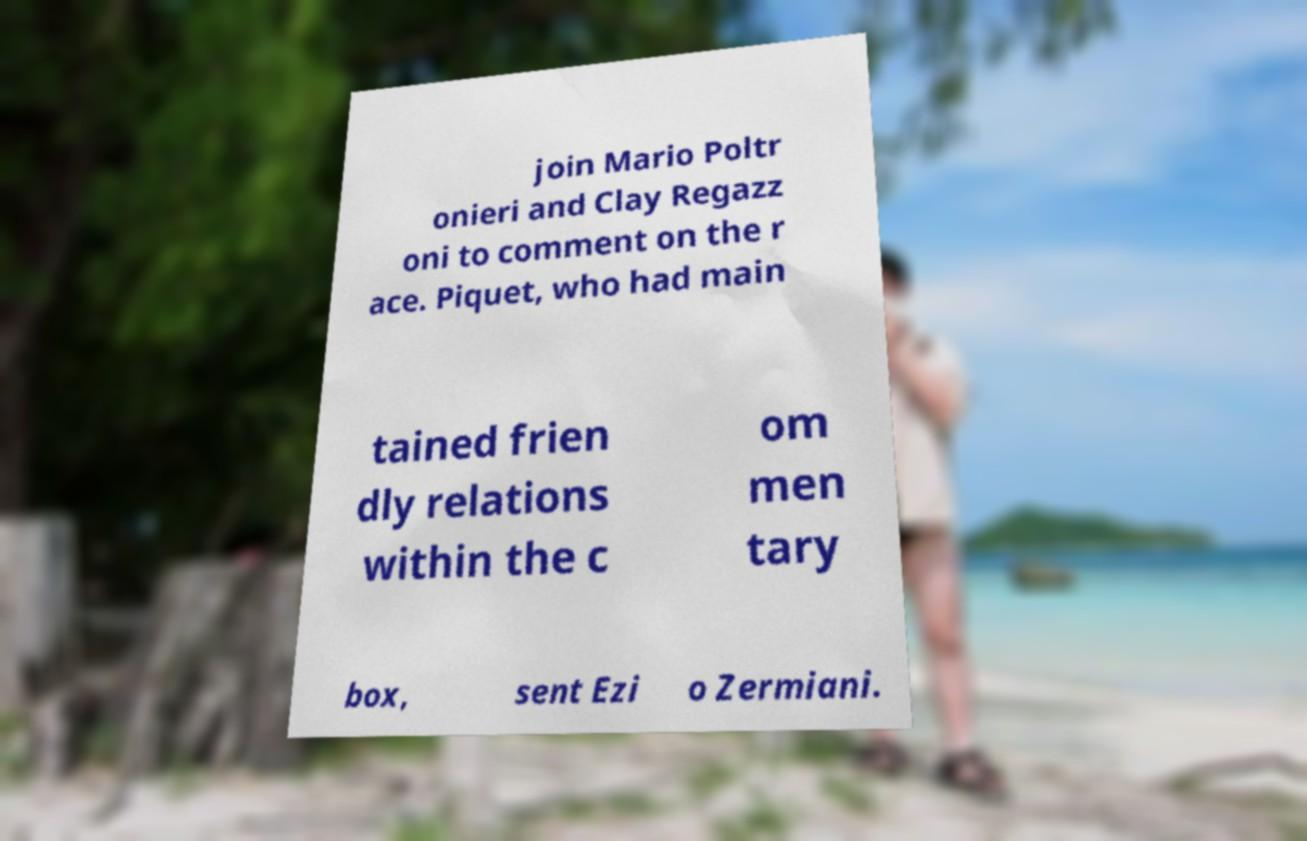I need the written content from this picture converted into text. Can you do that? join Mario Poltr onieri and Clay Regazz oni to comment on the r ace. Piquet, who had main tained frien dly relations within the c om men tary box, sent Ezi o Zermiani. 